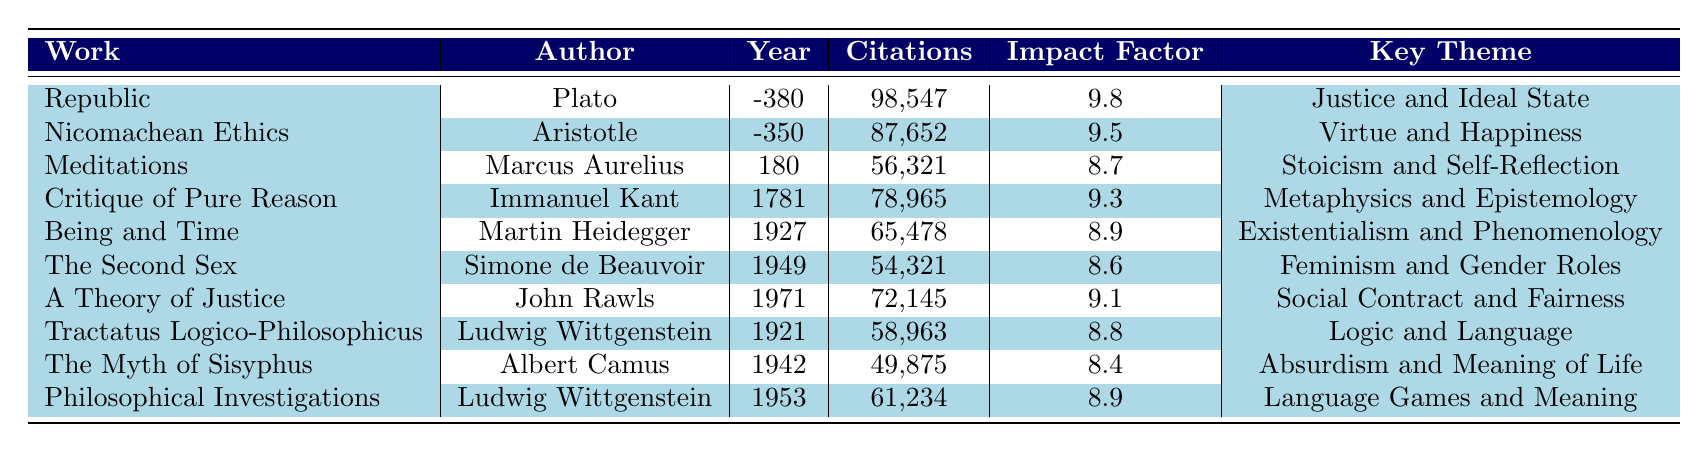What work has the highest number of citations? "Republic" by Plato has the highest citations with 98,547 as recorded in the table.
Answer: "Republic" Who is the author of "The Second Sex"? The author listed for "The Second Sex" is Simone de Beauvoir.
Answer: Simone de Beauvoir What is the impact factor of "Being and Time"? According to the table, the impact factor of "Being and Time" is 8.9.
Answer: 8.9 Which work has more citations: "Critique of Pure Reason" or "Nicomachean Ethics"? "Critique of Pure Reason" has 78,965 citations, while "Nicomachean Ethics" has 87,652. Since 87,652 > 78,965, "Nicomachean Ethics" has more citations.
Answer: "Nicomachean Ethics" What is the average impact factor of works by Ludwig Wittgenstein? The works attributed to Ludwig Wittgenstein are "Tractatus Logico-Philosophicus" (8.8) and "Philosophical Investigations" (8.9). Adding these, the sum is 17.7, divided by 2 gives an average impact factor of 8.85.
Answer: 8.85 Is "Meditations" published before "Nicomachean Ethics"? "Meditations" was published in 180 and "Nicomachean Ethics" in -350. Since -350 < 180, "Nicomachean Ethics" was published earlier.
Answer: No Which key theme has influenced more modern works, "Feminism and Gender Roles" or "Stoicism and Self-Reflection"? By reviewing the citations, "Feminism and Gender Roles" from "The Second Sex" has 54,321 citations, while "Stoicism and Self-Reflection" from "Meditations" has 56,321 citations. "Stoicism and Self-Reflection" has more citations, indicating a greater influence in modern perspectives.
Answer: "Stoicism and Self-Reflection" Calculate the total number of citations for all works authored by Aristotle. The only work by Aristotle listed is "Nicomachean Ethics" which has 87,652 citations. Thus, the total citations for works by Aristotle is 87,652.
Answer: 87,652 What is the difference in impact factor between "The Myth of Sisyphus" and "A Theory of Justice"? "The Myth of Sisyphus" has an impact factor of 8.4, while "A Theory of Justice" has 9.1. The difference is 9.1 - 8.4 = 0.7.
Answer: 0.7 Which author has written works that appear in the table more than once? The author Ludwig Wittgenstein is listed twice with "Tractatus Logico-Philosophicus" and "Philosophical Investigations".
Answer: Ludwig Wittgenstein 